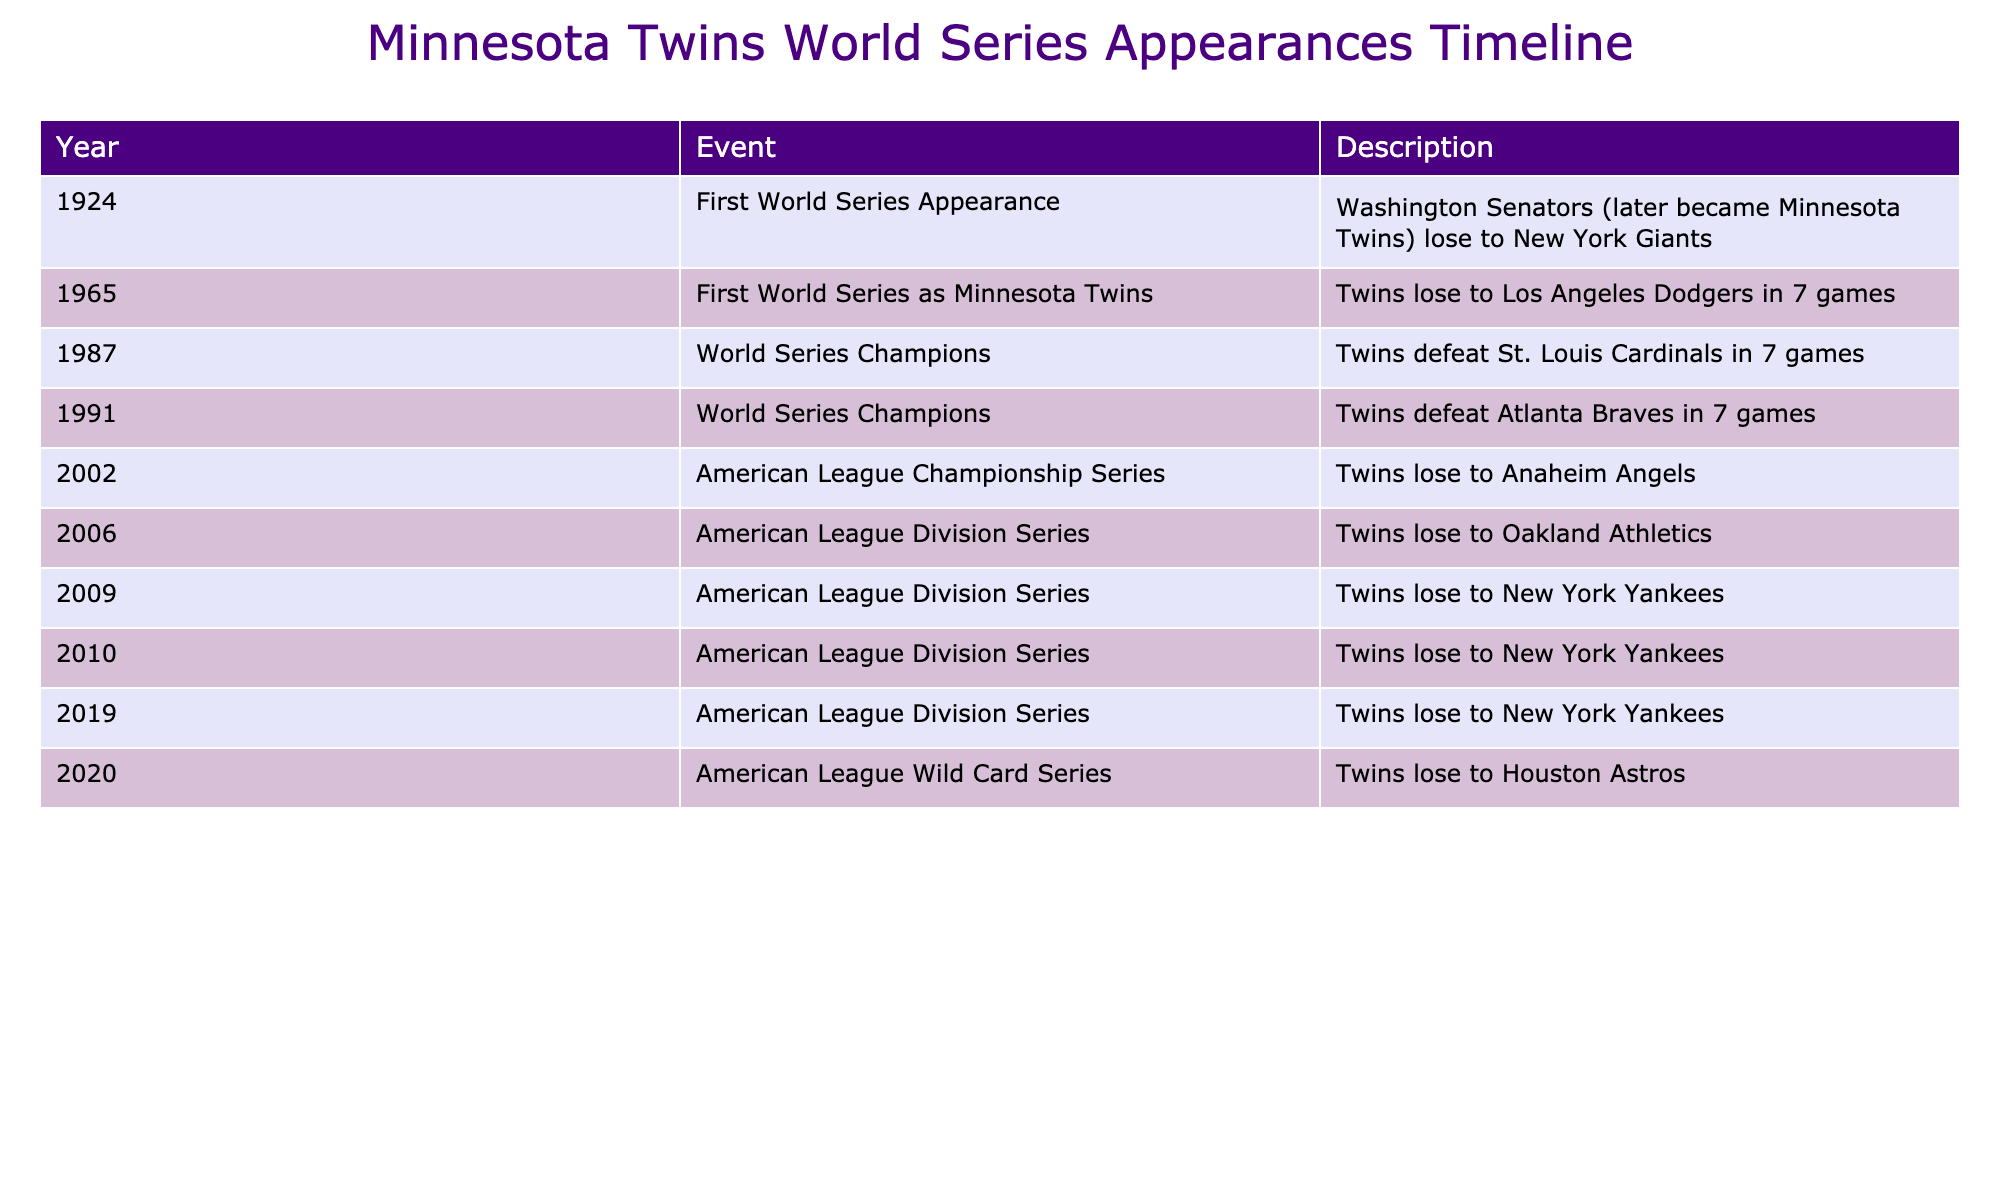What year did the Minnesota Twins first appear in the World Series? The table indicates that the first World Series appearance by the Minnesota Twins was in 1965. The event directly states this as the year of their first World Series as the Minnesota Twins.
Answer: 1965 How many times did the Minnesota Twins win the World Series? According to the table, the Minnesota Twins won the World Series twice, as indicated by the "World Series Champions" events in 1987 and 1991.
Answer: 2 Was there any year when the Minnesota Twins lost the World Series? Yes, the table shows that in 1965, the Twins lost the World Series to the Los Angeles Dodgers, marking a loss in the championship series.
Answer: Yes In which years did the Minnesota Twins lose in the American League Division Series? From the table, the Twins lost in the American League Division Series in 2006, 2009, and 2010, so these years can be listed from the respective events.
Answer: 2006, 2009, 2010 What is the difference in years between the Minnesota Twins first World Series appearance and their first championship win? The first World Series appearance was in 1965 and their first championship win was in 1987. The difference in years is calculated by subtracting 1965 from 1987, which equals 22 years.
Answer: 22 years How many games did it take the Minnesota Twins to win each of their World Series championships? The table shows that both championship wins in 1987 and 1991 were won in 7 games, as stated in the respective events. This means they won both series in the maximum number of games possible for a 7-game series.
Answer: 7 games Did the Minnesota Twins ever lose to the New York Yankees in the playoffs? Yes, the table indicates that the Twins lost to the New York Yankees in the American League Division Series three times: in 2009, 2010, and 2019.
Answer: Yes What was the outcome of the Minnesota Twins' appearance in the 1991 World Series? The table states that in 1991, the Minnesota Twins won the World Series, defeating the Atlanta Braves in 7 games. This shows their successful championship run that year.
Answer: Won 